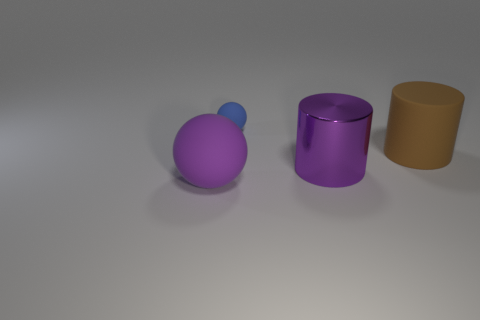Are there any other things that have the same material as the purple cylinder?
Give a very brief answer. No. There is a rubber object in front of the brown object; is there a thing that is behind it?
Your response must be concise. Yes. How many small things are gray rubber cylinders or blue balls?
Your response must be concise. 1. Are there any other cylinders of the same size as the purple cylinder?
Your response must be concise. Yes. How many rubber things are either brown things or large purple balls?
Offer a very short reply. 2. What is the shape of the object that is the same color as the large rubber sphere?
Offer a terse response. Cylinder. What number of spheres are there?
Provide a succinct answer. 2. Do the big cylinder that is behind the big metal thing and the big purple thing that is right of the large sphere have the same material?
Your answer should be compact. No. What is the size of the blue thing that is made of the same material as the big brown cylinder?
Provide a succinct answer. Small. What is the shape of the large matte object in front of the large brown matte thing?
Your answer should be very brief. Sphere. 